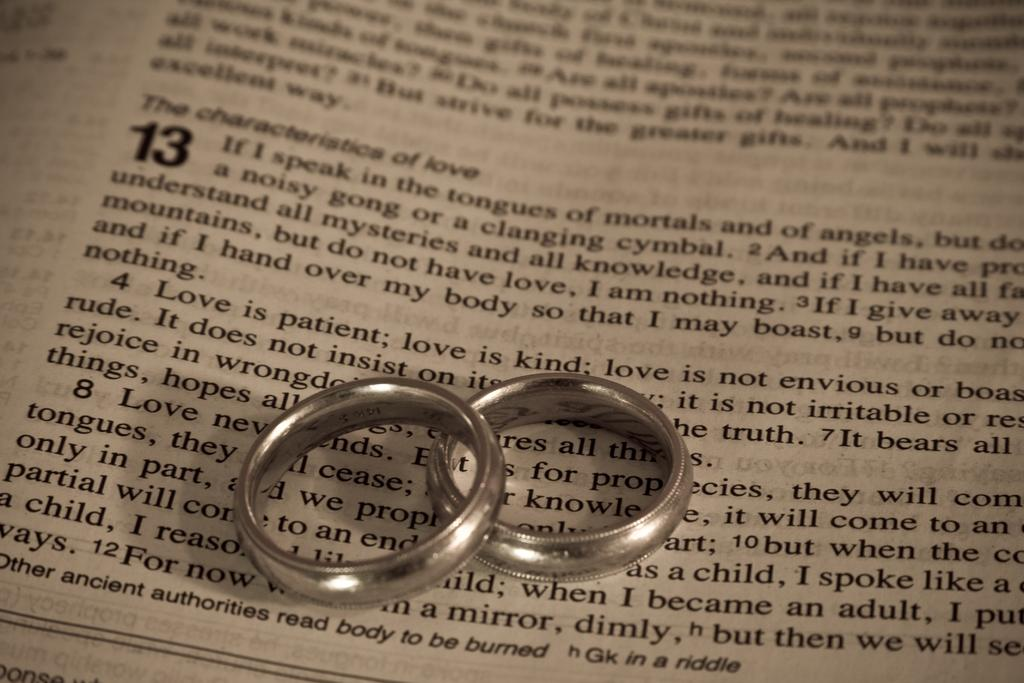<image>
Present a compact description of the photo's key features. Two rings on top of a book where the paragraphs start with "The characteristics of love". 